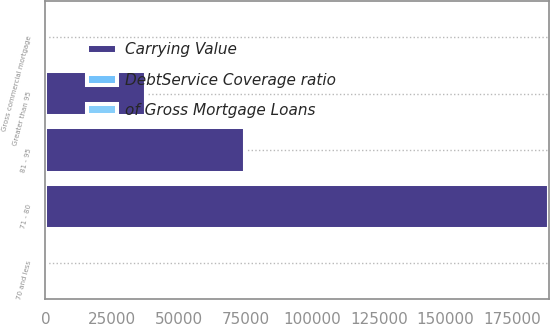<chart> <loc_0><loc_0><loc_500><loc_500><stacked_bar_chart><ecel><fcel>70 and less<fcel>71 - 80<fcel>81 - 95<fcel>Greater than 95<fcel>Gross commercial mortgage<nl><fcel>Carrying Value<fcel>5.7<fcel>188816<fcel>74657<fcel>37697<fcel>5.7<nl><fcel>DebtService Coverage ratio<fcel>77.1<fcel>14.3<fcel>5.7<fcel>2.9<fcel>100<nl><fcel>of Gross Mortgage Loans<fcel>2.09<fcel>1.37<fcel>1.16<fcel>0.76<fcel>1.9<nl></chart> 